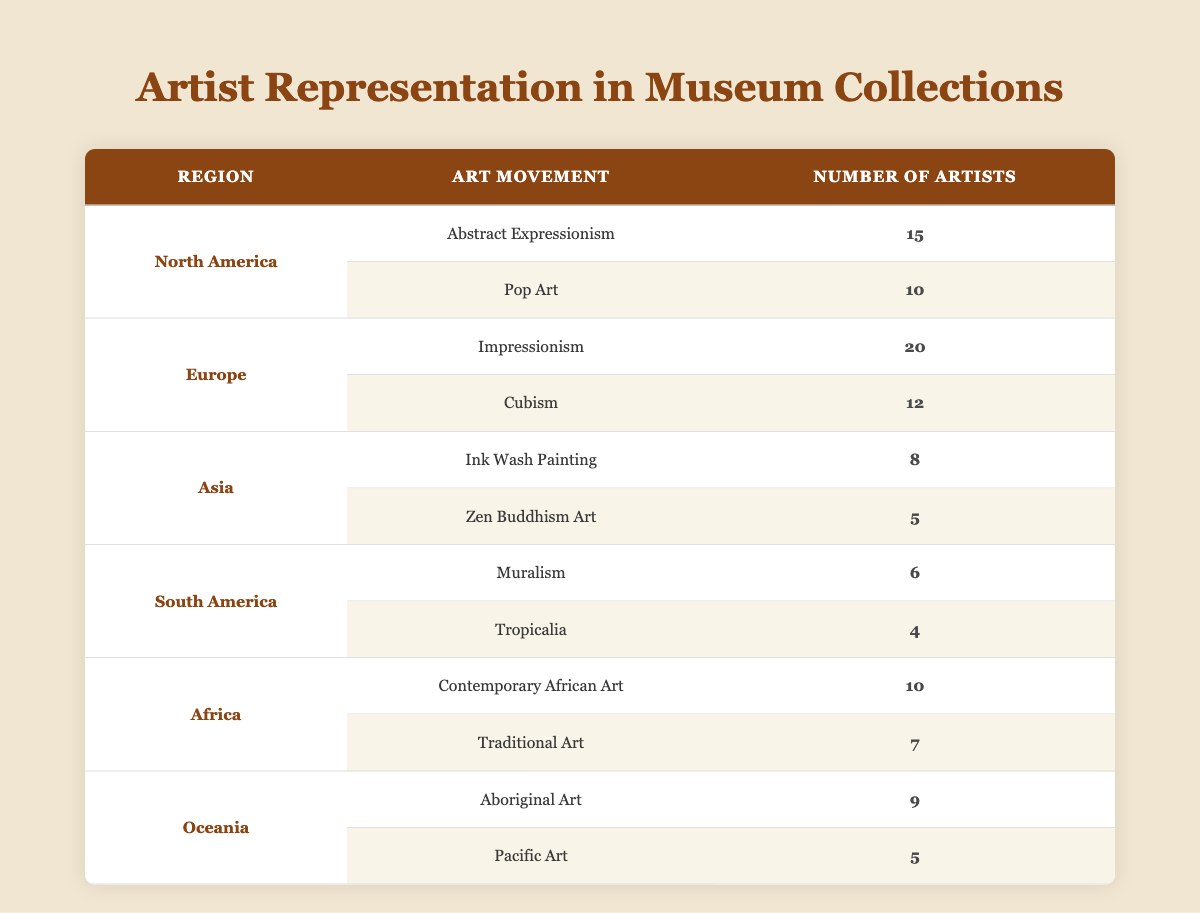What is the total number of artists from North America? To find the total number of artists from North America, we need to sum the number of artists in both art movements listed under that region: 15 (Abstract Expressionism) + 10 (Pop Art) = 25
Answer: 25 Which region has the highest representation of artists in any single art movement? Referring to the table, we can see that Europe has the highest representation with 20 artists in Impressionism. Other art movements don't surpass this number.
Answer: Europe (Impressionism) Are there more artists represented in Asia than in South America? By adding both art movements in Asia, we have 8 (Ink Wash Painting) + 5 (Zen Buddhism Art) = 13 artists. In South America, 6 (Muralism) + 4 (Tropicalia) = 10 artists. Since 13 is greater than 10, there are indeed more artists in Asia.
Answer: Yes What is the average number of artists represented in the art movements from Oceania? There are two art movements in Oceania: Aboriginal Art (9 artists) and Pacific Art (5 artists). We calculate the average by adding these numbers: 9 + 5 = 14. Then we divide by the number of movements (2): 14 / 2 = 7.
Answer: 7 Is it true that African artists in Contemporary African Art exceed the number of artists in Zen Buddhism Art? Comparing the two, Contemporary African Art has 10 artists, while Zen Buddhism Art has 5 artists. Since 10 is greater than 5, the statement is true.
Answer: Yes How many fewer artists are represented in South America compared to Europe? Europe has a total of 32 artists (20 in Impressionism + 12 in Cubism), while South America has 10 artists (6 in Muralism + 4 in Tropicalia). The difference is 32 - 10 = 22.
Answer: 22 What percentage of the total artists from the table are from North America? First, we find the total number of artists in the table: 15 + 10 + 20 + 12 + 8 + 5 + 6 + 4 + 10 + 7 + 9 + 5 =  100. Then we look at North America which has 25 artists; (25 / 100) * 100 = 25%.
Answer: 25% How does the total number of artists in Europe compare with the total number of artists in Africa? Adding for Europe gives us 32 artists (20 + 12), and for Africa, we have 17 artists (10 + 7). Comparing these totals: 32 (Europe) is greater than 17 (Africa).
Answer: Europe has more artists 